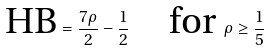<formula> <loc_0><loc_0><loc_500><loc_500>\text {HB} = \frac { 7 \rho } { 2 } - \frac { 1 } { 2 } \quad \text {for } \rho \geq \frac { 1 } { 5 }</formula> 